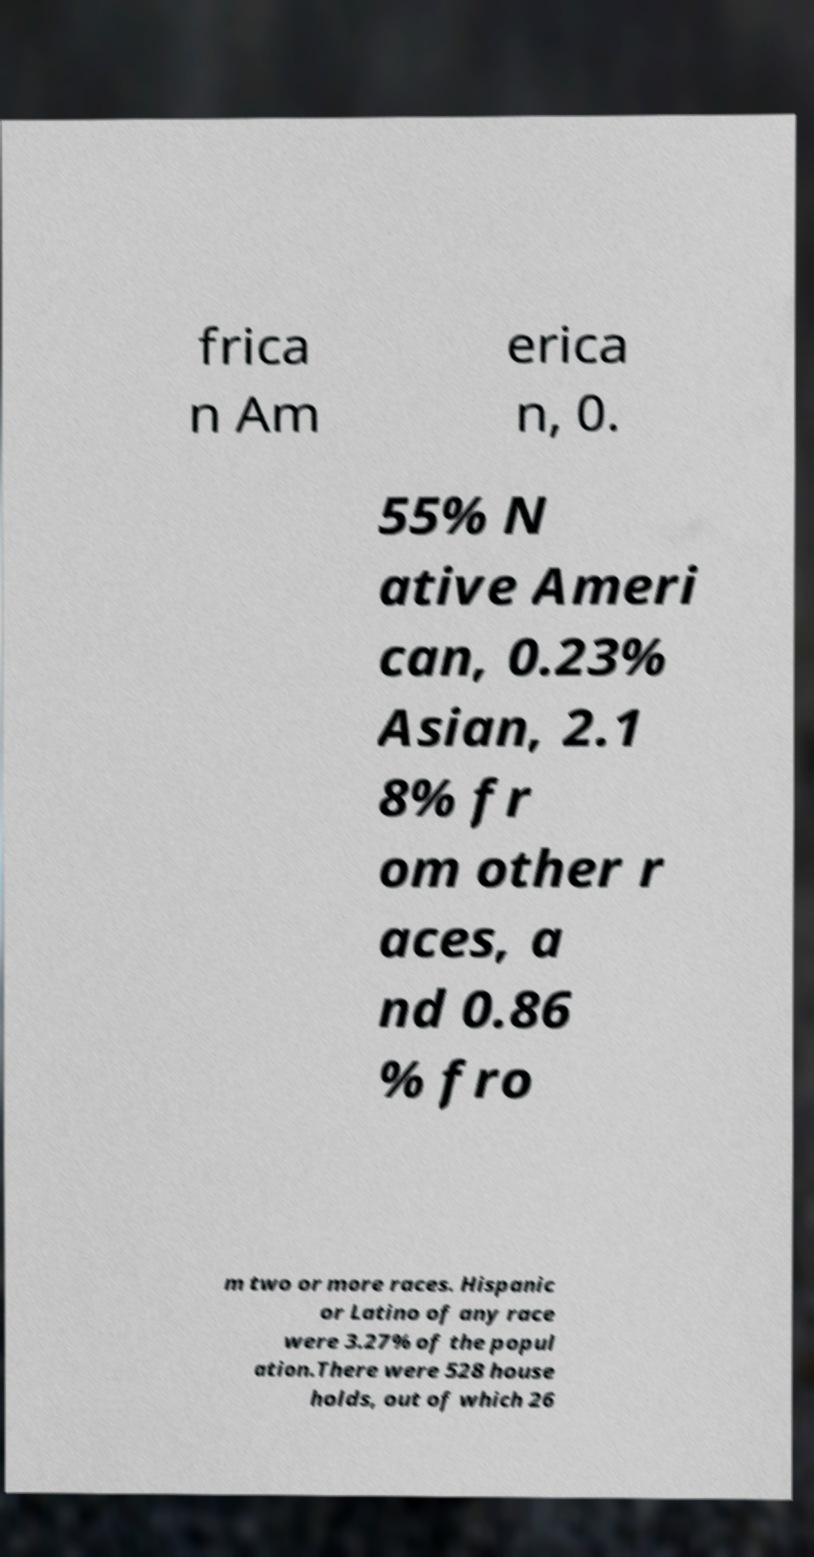Please read and relay the text visible in this image. What does it say? frica n Am erica n, 0. 55% N ative Ameri can, 0.23% Asian, 2.1 8% fr om other r aces, a nd 0.86 % fro m two or more races. Hispanic or Latino of any race were 3.27% of the popul ation.There were 528 house holds, out of which 26 